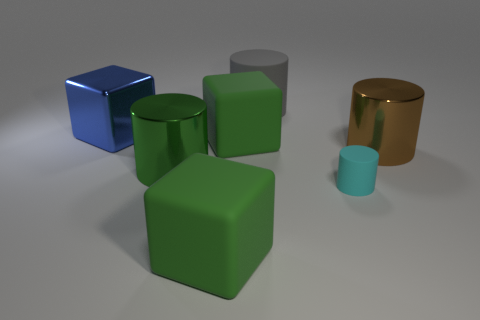Subtract all small cyan matte cylinders. How many cylinders are left? 3 Subtract 3 cubes. How many cubes are left? 0 Add 1 big cyan matte things. How many objects exist? 8 Subtract all cubes. How many objects are left? 4 Subtract all green blocks. How many blocks are left? 1 Subtract all red cylinders. Subtract all green balls. How many cylinders are left? 4 Subtract all blue balls. How many blue blocks are left? 1 Subtract all big green objects. Subtract all big rubber cylinders. How many objects are left? 3 Add 2 large green metallic cylinders. How many large green metallic cylinders are left? 3 Add 1 blue balls. How many blue balls exist? 1 